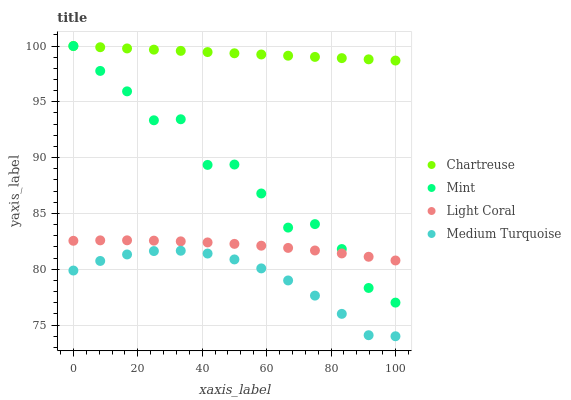Does Medium Turquoise have the minimum area under the curve?
Answer yes or no. Yes. Does Chartreuse have the maximum area under the curve?
Answer yes or no. Yes. Does Mint have the minimum area under the curve?
Answer yes or no. No. Does Mint have the maximum area under the curve?
Answer yes or no. No. Is Chartreuse the smoothest?
Answer yes or no. Yes. Is Mint the roughest?
Answer yes or no. Yes. Is Mint the smoothest?
Answer yes or no. No. Is Chartreuse the roughest?
Answer yes or no. No. Does Medium Turquoise have the lowest value?
Answer yes or no. Yes. Does Mint have the lowest value?
Answer yes or no. No. Does Mint have the highest value?
Answer yes or no. Yes. Does Medium Turquoise have the highest value?
Answer yes or no. No. Is Medium Turquoise less than Light Coral?
Answer yes or no. Yes. Is Chartreuse greater than Light Coral?
Answer yes or no. Yes. Does Mint intersect Light Coral?
Answer yes or no. Yes. Is Mint less than Light Coral?
Answer yes or no. No. Is Mint greater than Light Coral?
Answer yes or no. No. Does Medium Turquoise intersect Light Coral?
Answer yes or no. No. 